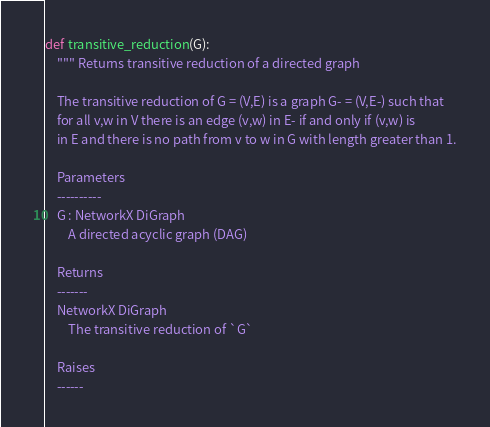Convert code to text. <code><loc_0><loc_0><loc_500><loc_500><_Python_>def transitive_reduction(G):
    """ Returns transitive reduction of a directed graph

    The transitive reduction of G = (V,E) is a graph G- = (V,E-) such that
    for all v,w in V there is an edge (v,w) in E- if and only if (v,w) is
    in E and there is no path from v to w in G with length greater than 1.

    Parameters
    ----------
    G : NetworkX DiGraph
        A directed acyclic graph (DAG)

    Returns
    -------
    NetworkX DiGraph
        The transitive reduction of `G`

    Raises
    ------</code> 